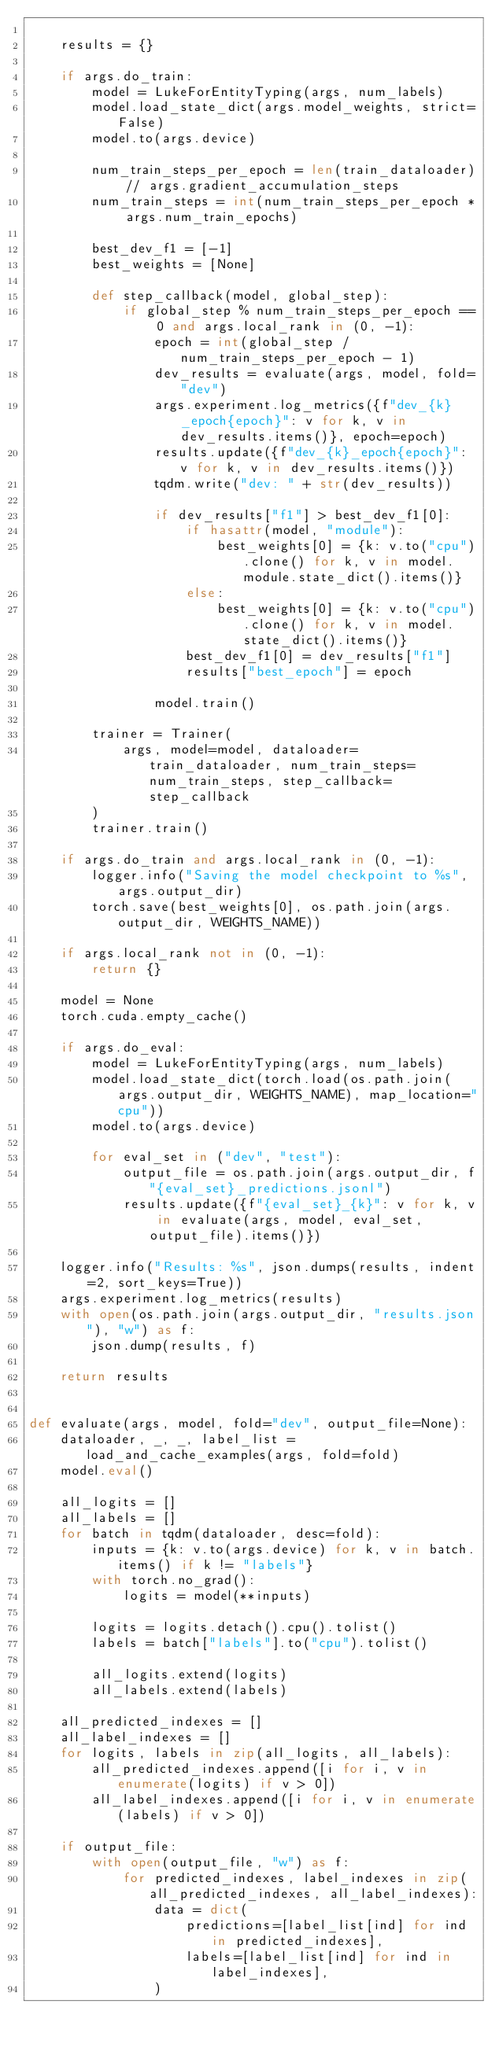<code> <loc_0><loc_0><loc_500><loc_500><_Python_>
    results = {}

    if args.do_train:
        model = LukeForEntityTyping(args, num_labels)
        model.load_state_dict(args.model_weights, strict=False)
        model.to(args.device)

        num_train_steps_per_epoch = len(train_dataloader) // args.gradient_accumulation_steps
        num_train_steps = int(num_train_steps_per_epoch * args.num_train_epochs)

        best_dev_f1 = [-1]
        best_weights = [None]

        def step_callback(model, global_step):
            if global_step % num_train_steps_per_epoch == 0 and args.local_rank in (0, -1):
                epoch = int(global_step / num_train_steps_per_epoch - 1)
                dev_results = evaluate(args, model, fold="dev")
                args.experiment.log_metrics({f"dev_{k}_epoch{epoch}": v for k, v in dev_results.items()}, epoch=epoch)
                results.update({f"dev_{k}_epoch{epoch}": v for k, v in dev_results.items()})
                tqdm.write("dev: " + str(dev_results))

                if dev_results["f1"] > best_dev_f1[0]:
                    if hasattr(model, "module"):
                        best_weights[0] = {k: v.to("cpu").clone() for k, v in model.module.state_dict().items()}
                    else:
                        best_weights[0] = {k: v.to("cpu").clone() for k, v in model.state_dict().items()}
                    best_dev_f1[0] = dev_results["f1"]
                    results["best_epoch"] = epoch

                model.train()

        trainer = Trainer(
            args, model=model, dataloader=train_dataloader, num_train_steps=num_train_steps, step_callback=step_callback
        )
        trainer.train()

    if args.do_train and args.local_rank in (0, -1):
        logger.info("Saving the model checkpoint to %s", args.output_dir)
        torch.save(best_weights[0], os.path.join(args.output_dir, WEIGHTS_NAME))

    if args.local_rank not in (0, -1):
        return {}

    model = None
    torch.cuda.empty_cache()

    if args.do_eval:
        model = LukeForEntityTyping(args, num_labels)
        model.load_state_dict(torch.load(os.path.join(args.output_dir, WEIGHTS_NAME), map_location="cpu"))
        model.to(args.device)

        for eval_set in ("dev", "test"):
            output_file = os.path.join(args.output_dir, f"{eval_set}_predictions.jsonl")
            results.update({f"{eval_set}_{k}": v for k, v in evaluate(args, model, eval_set, output_file).items()})

    logger.info("Results: %s", json.dumps(results, indent=2, sort_keys=True))
    args.experiment.log_metrics(results)
    with open(os.path.join(args.output_dir, "results.json"), "w") as f:
        json.dump(results, f)

    return results


def evaluate(args, model, fold="dev", output_file=None):
    dataloader, _, _, label_list = load_and_cache_examples(args, fold=fold)
    model.eval()

    all_logits = []
    all_labels = []
    for batch in tqdm(dataloader, desc=fold):
        inputs = {k: v.to(args.device) for k, v in batch.items() if k != "labels"}
        with torch.no_grad():
            logits = model(**inputs)

        logits = logits.detach().cpu().tolist()
        labels = batch["labels"].to("cpu").tolist()

        all_logits.extend(logits)
        all_labels.extend(labels)

    all_predicted_indexes = []
    all_label_indexes = []
    for logits, labels in zip(all_logits, all_labels):
        all_predicted_indexes.append([i for i, v in enumerate(logits) if v > 0])
        all_label_indexes.append([i for i, v in enumerate(labels) if v > 0])

    if output_file:
        with open(output_file, "w") as f:
            for predicted_indexes, label_indexes in zip(all_predicted_indexes, all_label_indexes):
                data = dict(
                    predictions=[label_list[ind] for ind in predicted_indexes],
                    labels=[label_list[ind] for ind in label_indexes],
                )</code> 